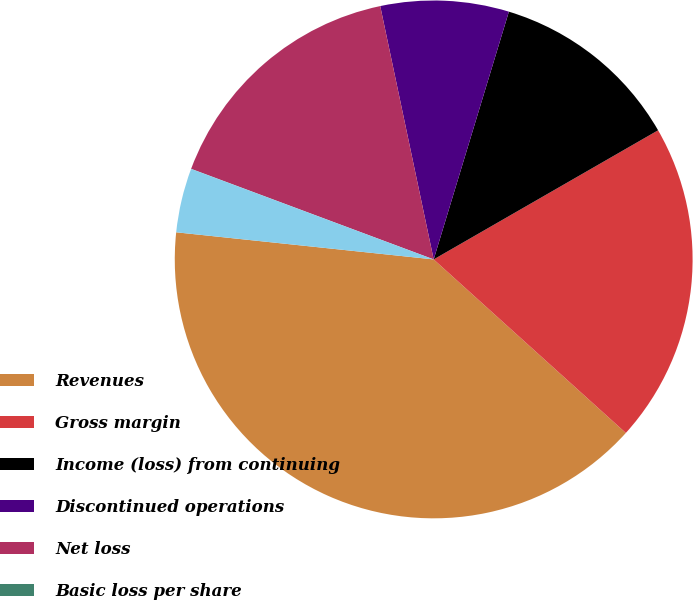Convert chart. <chart><loc_0><loc_0><loc_500><loc_500><pie_chart><fcel>Revenues<fcel>Gross margin<fcel>Income (loss) from continuing<fcel>Discontinued operations<fcel>Net loss<fcel>Basic loss per share<fcel>Diluted loss per share<nl><fcel>39.98%<fcel>20.0%<fcel>12.0%<fcel>8.0%<fcel>16.0%<fcel>0.01%<fcel>4.01%<nl></chart> 